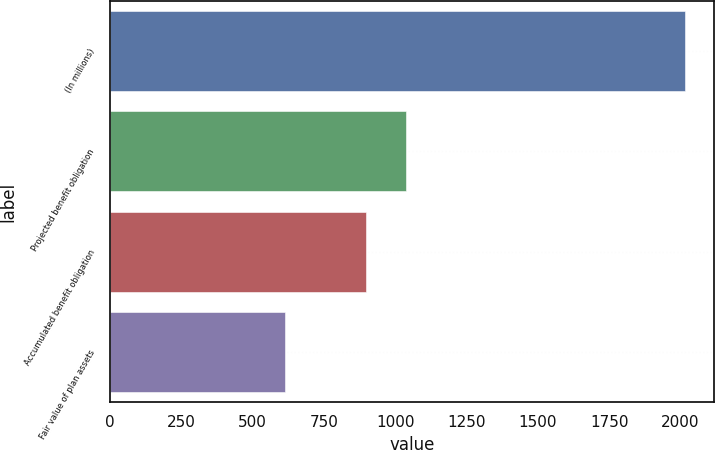Convert chart to OTSL. <chart><loc_0><loc_0><loc_500><loc_500><bar_chart><fcel>(In millions)<fcel>Projected benefit obligation<fcel>Accumulated benefit obligation<fcel>Fair value of plan assets<nl><fcel>2015<fcel>1037.3<fcel>897<fcel>612<nl></chart> 